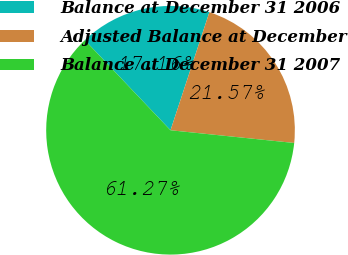Convert chart. <chart><loc_0><loc_0><loc_500><loc_500><pie_chart><fcel>Balance at December 31 2006<fcel>Adjusted Balance at December<fcel>Balance at December 31 2007<nl><fcel>17.16%<fcel>21.57%<fcel>61.27%<nl></chart> 